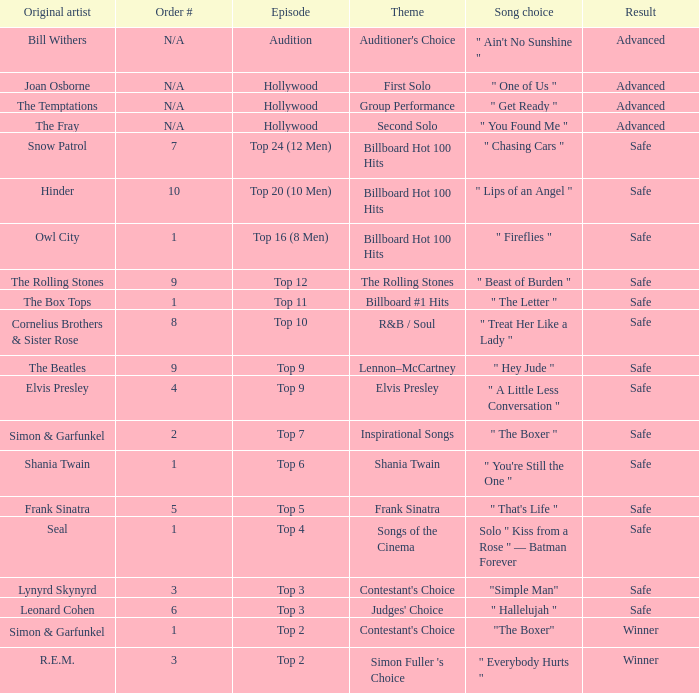The original artist Joan Osborne has what result? Advanced. 